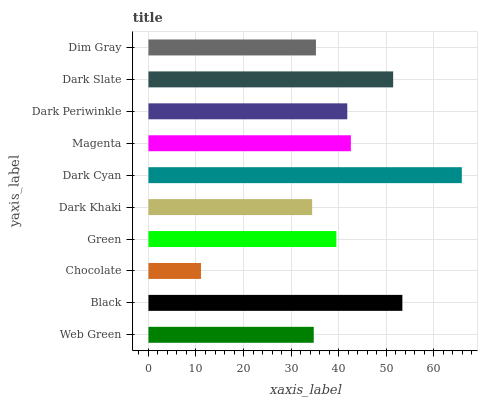Is Chocolate the minimum?
Answer yes or no. Yes. Is Dark Cyan the maximum?
Answer yes or no. Yes. Is Black the minimum?
Answer yes or no. No. Is Black the maximum?
Answer yes or no. No. Is Black greater than Web Green?
Answer yes or no. Yes. Is Web Green less than Black?
Answer yes or no. Yes. Is Web Green greater than Black?
Answer yes or no. No. Is Black less than Web Green?
Answer yes or no. No. Is Dark Periwinkle the high median?
Answer yes or no. Yes. Is Green the low median?
Answer yes or no. Yes. Is Magenta the high median?
Answer yes or no. No. Is Magenta the low median?
Answer yes or no. No. 